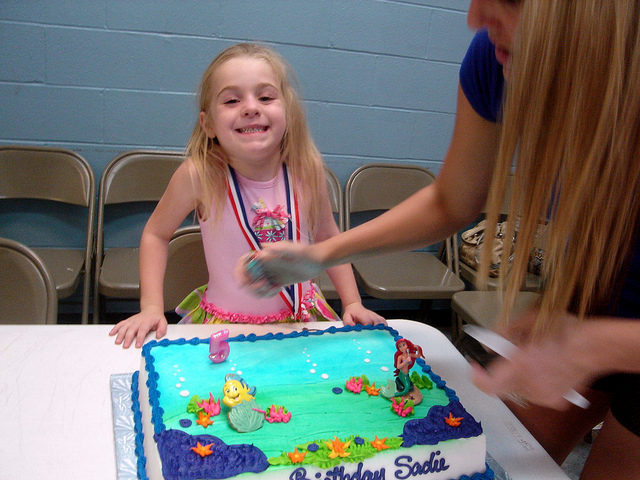Please transcribe the text in this image. SADIL 5 